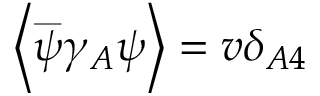<formula> <loc_0><loc_0><loc_500><loc_500>\left \langle \overset { \_ } { \psi } \gamma _ { A } \psi \right \rangle = v \delta _ { A 4 }</formula> 